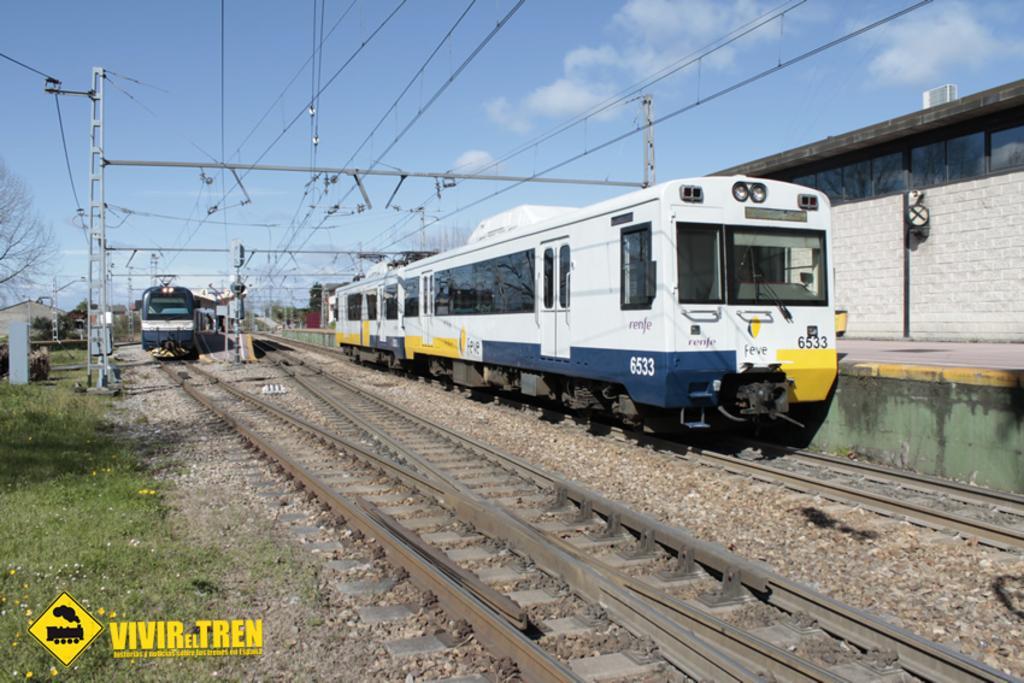Describe this image in one or two sentences. In this picture I can see couple trains on the railway tracks and I can see trees, buildings and text at the bottom left corner of the picture and I can see a logo and a blue cloudy sky. 